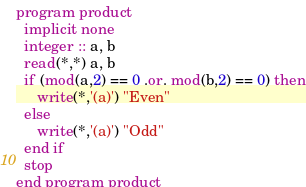Convert code to text. <code><loc_0><loc_0><loc_500><loc_500><_FORTRAN_>program product
  implicit none
  integer :: a, b
  read(*,*) a, b
  if (mod(a,2) == 0 .or. mod(b,2) == 0) then
     write(*,'(a)') "Even"
  else
     write(*,'(a)') "Odd"
  end if
  stop
end program product</code> 